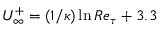<formula> <loc_0><loc_0><loc_500><loc_500>U _ { \infty } ^ { + } = ( 1 / \kappa ) \ln R e _ { \tau } + 3 . 3</formula> 